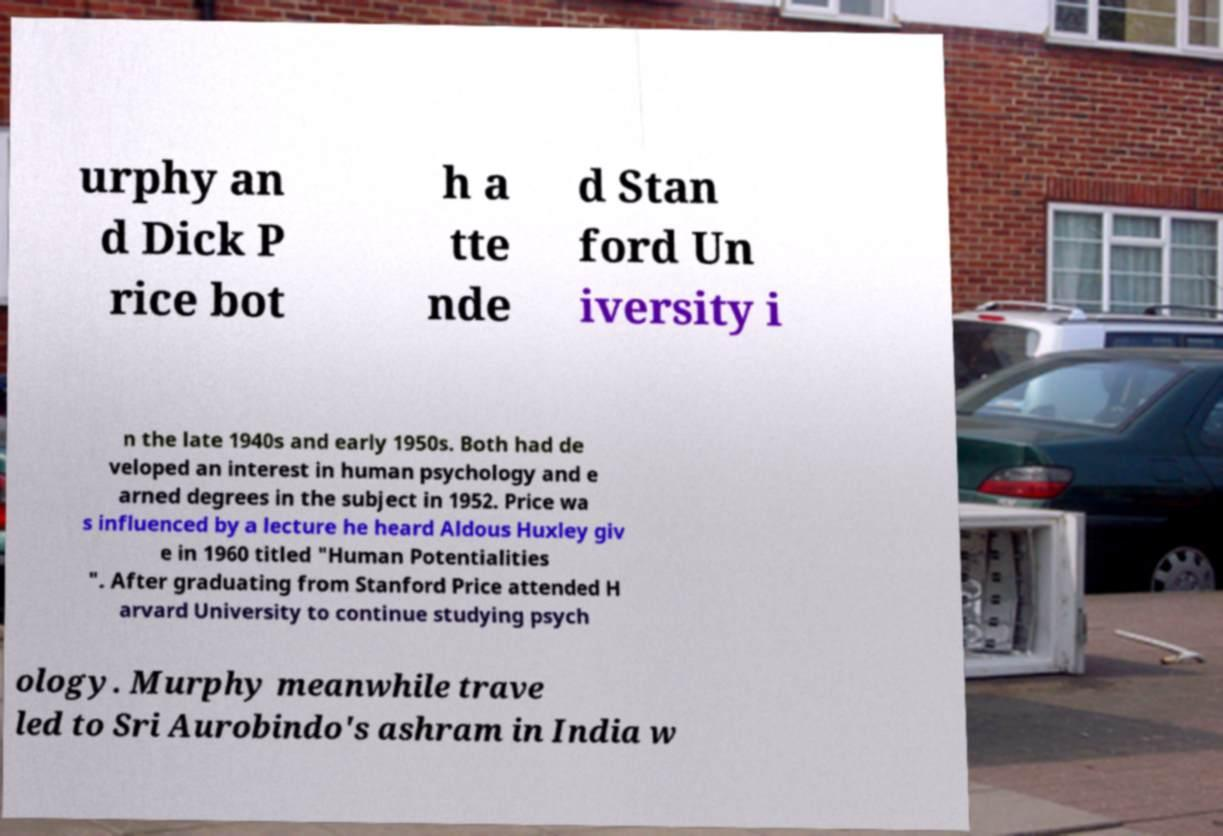For documentation purposes, I need the text within this image transcribed. Could you provide that? urphy an d Dick P rice bot h a tte nde d Stan ford Un iversity i n the late 1940s and early 1950s. Both had de veloped an interest in human psychology and e arned degrees in the subject in 1952. Price wa s influenced by a lecture he heard Aldous Huxley giv e in 1960 titled "Human Potentialities ". After graduating from Stanford Price attended H arvard University to continue studying psych ology. Murphy meanwhile trave led to Sri Aurobindo's ashram in India w 